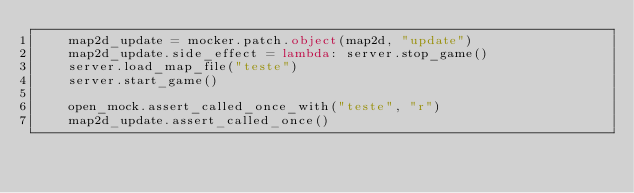Convert code to text. <code><loc_0><loc_0><loc_500><loc_500><_Python_>    map2d_update = mocker.patch.object(map2d, "update")
    map2d_update.side_effect = lambda: server.stop_game()
    server.load_map_file("teste")
    server.start_game()

    open_mock.assert_called_once_with("teste", "r")
    map2d_update.assert_called_once()
</code> 